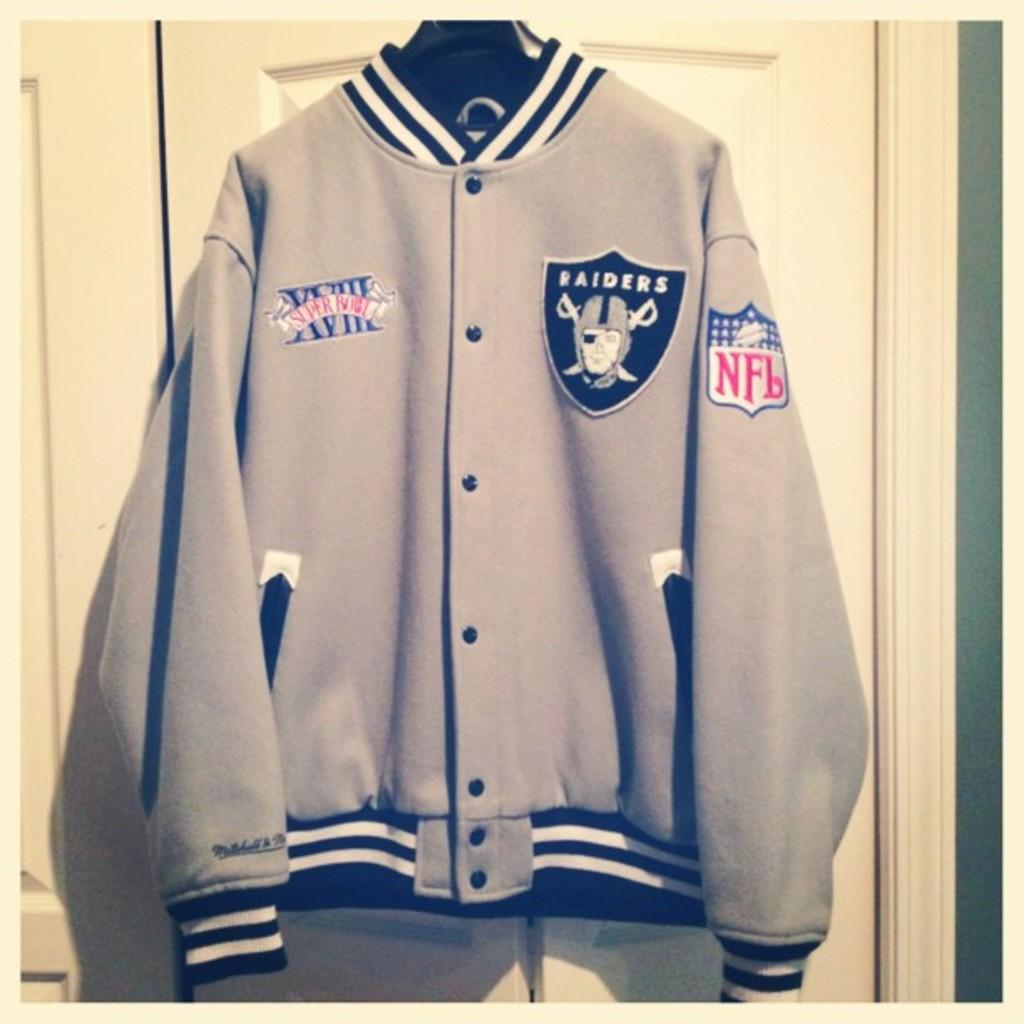<image>
Provide a brief description of the given image. a Raiders jacket is in the closet with an NFL logo on he sleeve 